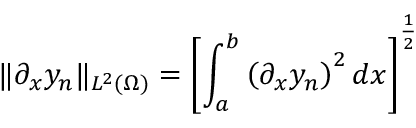<formula> <loc_0><loc_0><loc_500><loc_500>\| \partial _ { x } y _ { n } \| _ { L ^ { 2 } ( \Omega ) } = \left [ \int _ { a } ^ { b } \left ( \partial _ { x } y _ { n } \right ) ^ { 2 } d x \right ] ^ { \frac { 1 } { 2 } }</formula> 